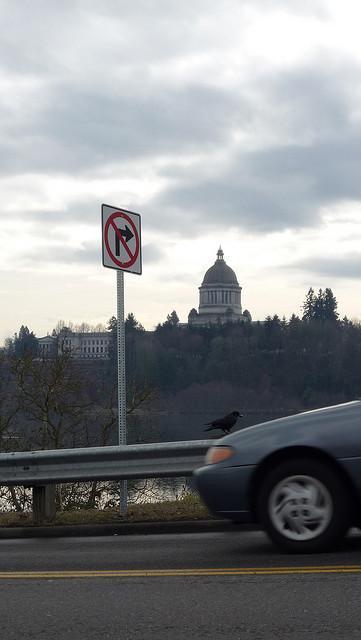How many people are holding tennis rackets?
Give a very brief answer. 0. 